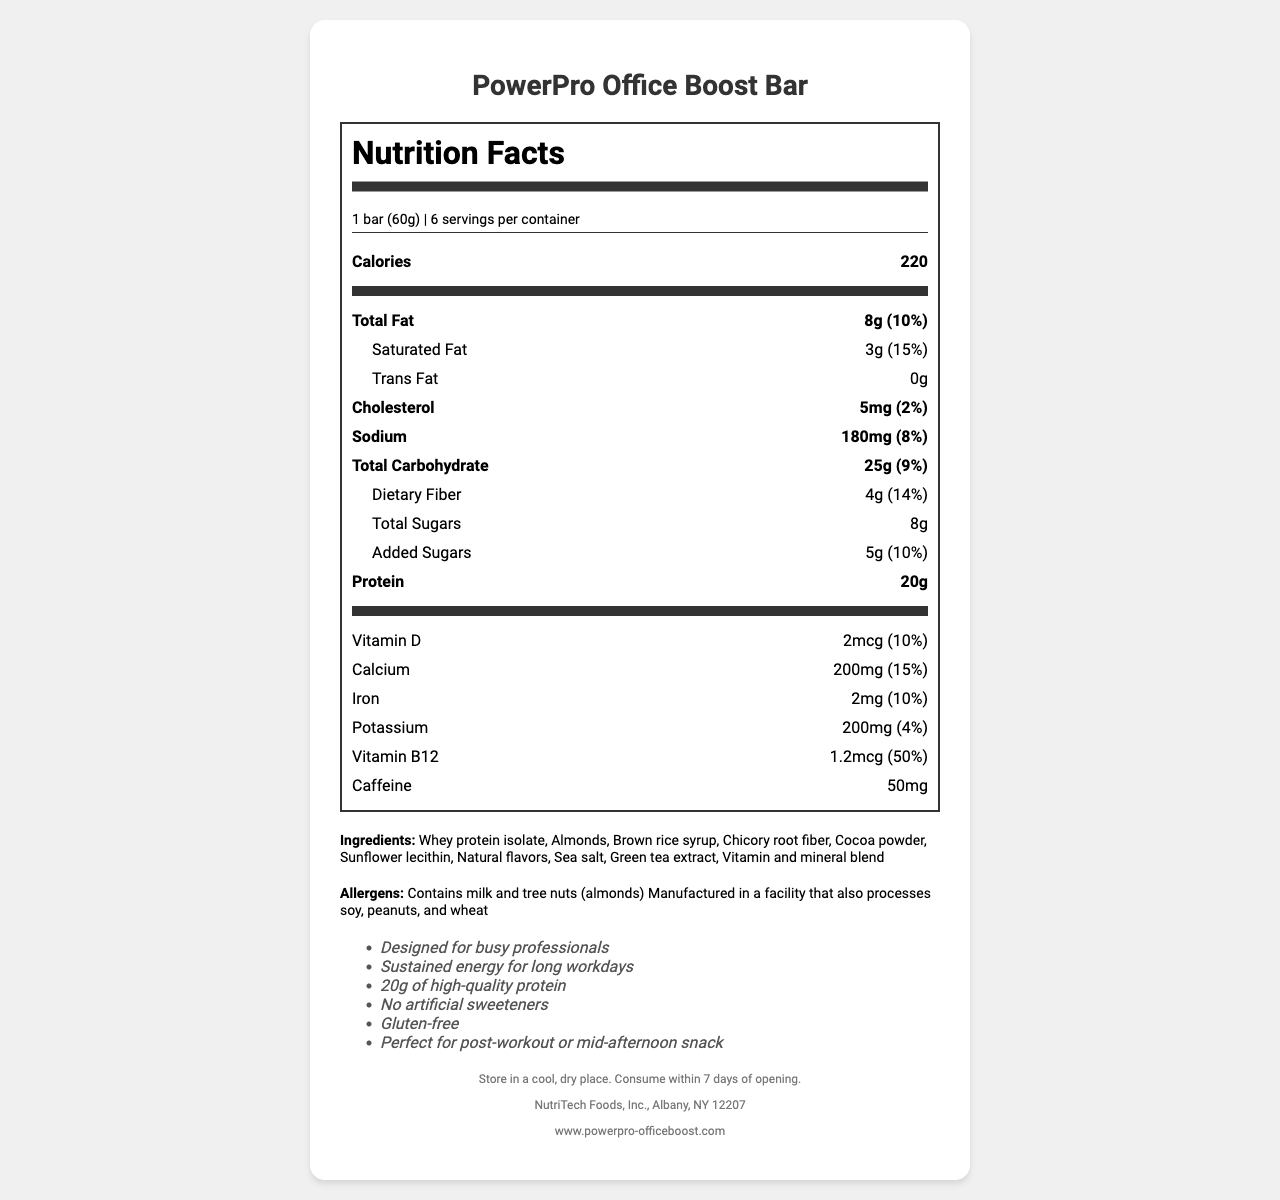what is the serving size of the PowerPro Office Boost Bar? The serving size is listed directly in the "serving-info" section of the document.
Answer: 1 bar (60g) how many servings are there per container? This information is listed under "serving-info" as "6 servings per container."
Answer: 6 how many calories are in one serving of the PowerPro Office Boost Bar? The calorie content for one serving is directly listed under the "Calories" section.
Answer: 220 what is the total amount of fat in one serving? The "Total Fat" amount is listed as 8g in the "nutrient-row."
Answer: 8g how much protein does one PowerPro Office Boost Bar contain? The amount of protein in one serving is listed in the "Protein" section.
Answer: 20g how much Vitamin B12 is in one PowerPro Office Boost Bar? The amount of Vitamin B12 is listed under the "Vitamin B12" section.
Answer: 1.2mcg does the PowerPro Office Boost Bar contain caffeine? The document lists "Caffeine: 50mg" under the nutrition label.
Answer: Yes how should the PowerPro Office Boost Bar be stored? The storage instructions are provided in the "footer" section of the document.
Answer: Store in a cool, dry place. Consume within 7 days of opening. which nutrients are listed with a daily value of 10%? A. Total Fat, Vitamin D, Iron B. Added Sugars, Vitamin B12 C. Iron, Sodium, Total Sugars D. Vitamin D, Calcium, Iron The percentages for Vitamin D, Calcium, and Iron are 10% each as listed in their respective rows.
Answer: D. Vitamin D, Calcium, Iron which of the following ingredients is NOT in the PowerPro Office Boost Bar? (i) Almonds (ii) Brown rice syrup (iii) Artificial sweeteners (iv) Cocoa powder The ingredients list does not include artificial sweeteners, and one of the marketing claims explicitly states "No artificial sweeteners."
Answer: iii. Artificial sweeteners is the PowerPro Office Boost Bar gluten-free? One of the marketing claims in the document explicitly states "Gluten-free."
Answer: Yes summarize the main idea of the document. The summary covers the key aspects of the document, including the intended audience, nutritional benefits, and ingredient information.
Answer: The document provides the nutrition facts, ingredients, allergens, and storage instructions for the "PowerPro Office Boost Bar." The bar is marketed towards busy professionals, offering sustained energy with 20g of high-quality protein, no artificial sweeteners, and gluten-free benefits. where is the PowerPro Office Boost Bar manufactured? The manufacturer's address is listed as "NutriTech Foods, Inc., Albany, NY 12207" in the footer of the document.
Answer: Albany, NY 12207 describe the texture or taste of the PowerPro Office Boost Bar. The document does not provide details on the texture or taste of the bar.
Answer: Not enough information 